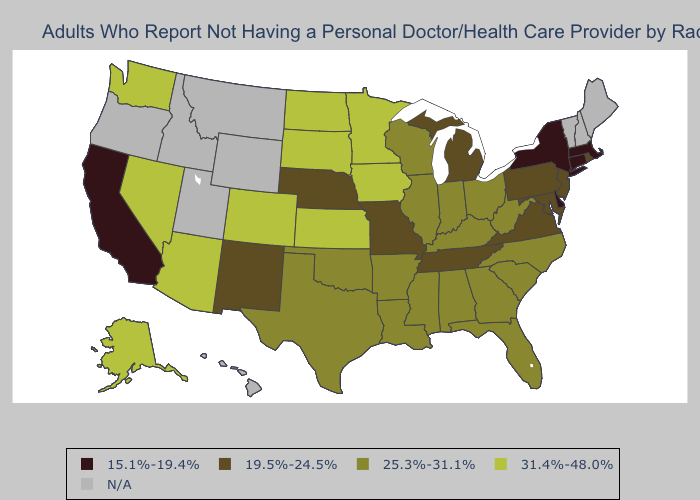Name the states that have a value in the range 25.3%-31.1%?
Quick response, please. Alabama, Arkansas, Florida, Georgia, Illinois, Indiana, Kentucky, Louisiana, Mississippi, North Carolina, Ohio, Oklahoma, South Carolina, Texas, West Virginia, Wisconsin. Which states have the highest value in the USA?
Answer briefly. Alaska, Arizona, Colorado, Iowa, Kansas, Minnesota, Nevada, North Dakota, South Dakota, Washington. Name the states that have a value in the range 31.4%-48.0%?
Give a very brief answer. Alaska, Arizona, Colorado, Iowa, Kansas, Minnesota, Nevada, North Dakota, South Dakota, Washington. Which states have the highest value in the USA?
Write a very short answer. Alaska, Arizona, Colorado, Iowa, Kansas, Minnesota, Nevada, North Dakota, South Dakota, Washington. Name the states that have a value in the range 31.4%-48.0%?
Short answer required. Alaska, Arizona, Colorado, Iowa, Kansas, Minnesota, Nevada, North Dakota, South Dakota, Washington. Which states have the lowest value in the USA?
Quick response, please. California, Connecticut, Delaware, Massachusetts, New York. Name the states that have a value in the range 15.1%-19.4%?
Short answer required. California, Connecticut, Delaware, Massachusetts, New York. What is the value of New Mexico?
Be succinct. 19.5%-24.5%. How many symbols are there in the legend?
Give a very brief answer. 5. Which states have the lowest value in the Northeast?
Answer briefly. Connecticut, Massachusetts, New York. Does the map have missing data?
Concise answer only. Yes. What is the value of Nebraska?
Be succinct. 19.5%-24.5%. How many symbols are there in the legend?
Quick response, please. 5. Among the states that border New Hampshire , which have the highest value?
Write a very short answer. Massachusetts. Name the states that have a value in the range 19.5%-24.5%?
Keep it brief. Maryland, Michigan, Missouri, Nebraska, New Jersey, New Mexico, Pennsylvania, Rhode Island, Tennessee, Virginia. 